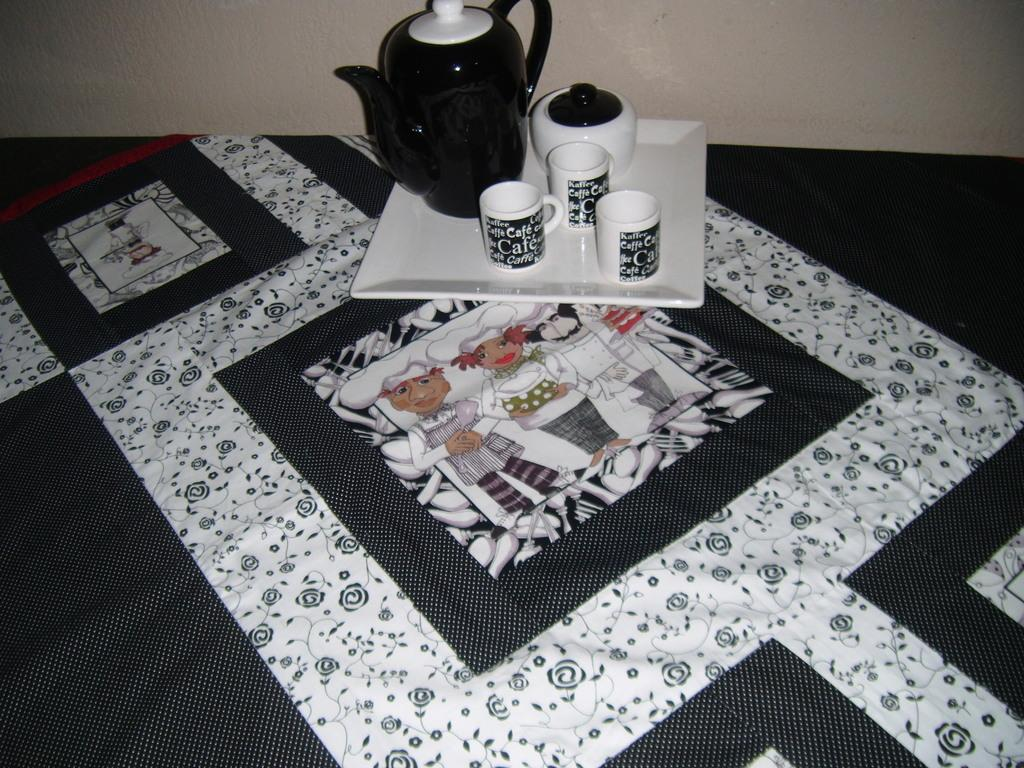What is the main object in the image? There is a tray in the image. What items are on the tray? There is a jar, three cups, and a bowl on the tray. What type of attraction can be seen in the image? There is no attraction present in the image; it features a tray with a jar, three cups, and a bowl. Is there any indication of pain or discomfort in the image? There is no indication of pain or discomfort in the image; it features a tray with a jar, three cups, and a bowl. 